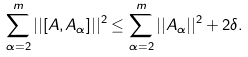<formula> <loc_0><loc_0><loc_500><loc_500>\sum _ { \alpha = 2 } ^ { m } | | [ A , A _ { \alpha } ] | | ^ { 2 } \leq \sum _ { \alpha = 2 } ^ { m } | | A _ { \alpha } | | ^ { 2 } + 2 \delta .</formula> 